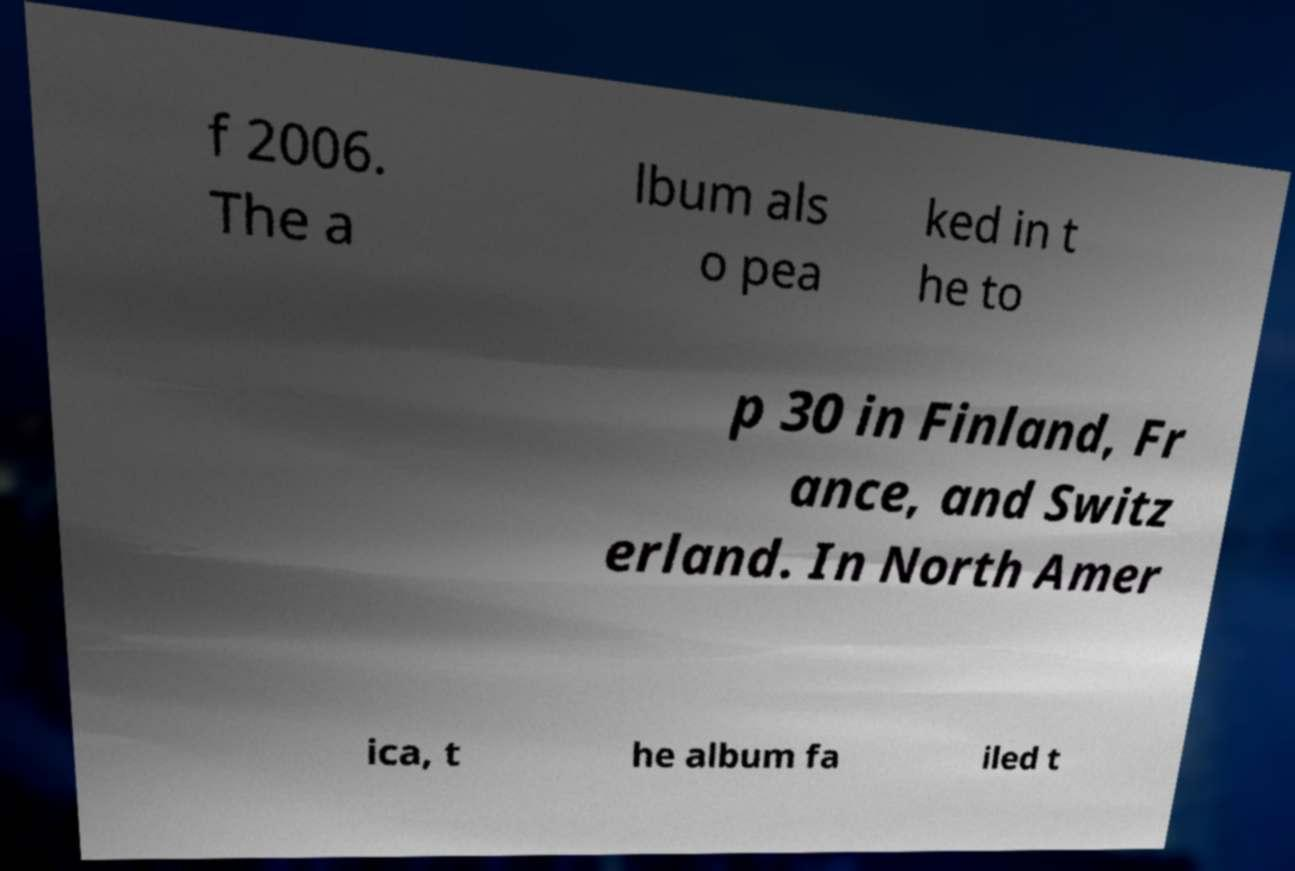Could you extract and type out the text from this image? f 2006. The a lbum als o pea ked in t he to p 30 in Finland, Fr ance, and Switz erland. In North Amer ica, t he album fa iled t 